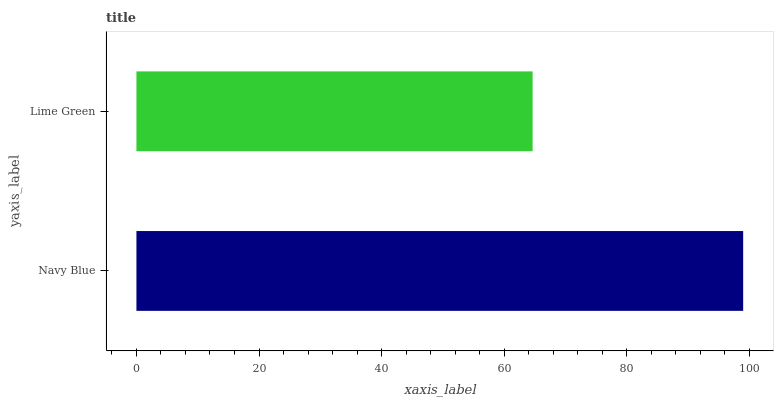Is Lime Green the minimum?
Answer yes or no. Yes. Is Navy Blue the maximum?
Answer yes or no. Yes. Is Lime Green the maximum?
Answer yes or no. No. Is Navy Blue greater than Lime Green?
Answer yes or no. Yes. Is Lime Green less than Navy Blue?
Answer yes or no. Yes. Is Lime Green greater than Navy Blue?
Answer yes or no. No. Is Navy Blue less than Lime Green?
Answer yes or no. No. Is Navy Blue the high median?
Answer yes or no. Yes. Is Lime Green the low median?
Answer yes or no. Yes. Is Lime Green the high median?
Answer yes or no. No. Is Navy Blue the low median?
Answer yes or no. No. 